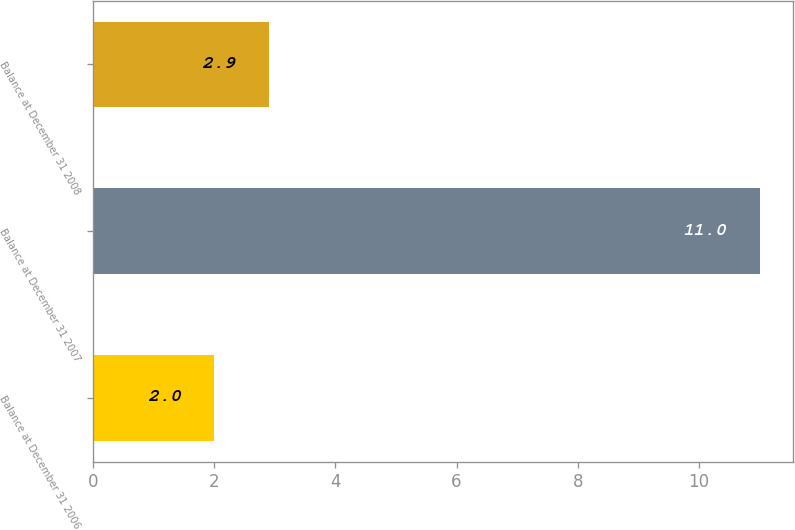<chart> <loc_0><loc_0><loc_500><loc_500><bar_chart><fcel>Balance at December 31 2006<fcel>Balance at December 31 2007<fcel>Balance at December 31 2008<nl><fcel>2<fcel>11<fcel>2.9<nl></chart> 